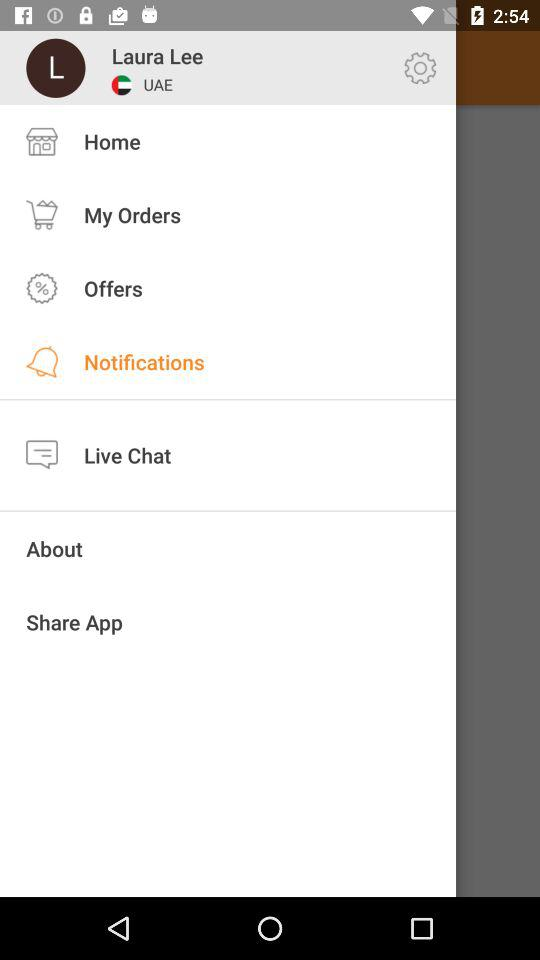What is the user name? The user name is Laura Lee. 